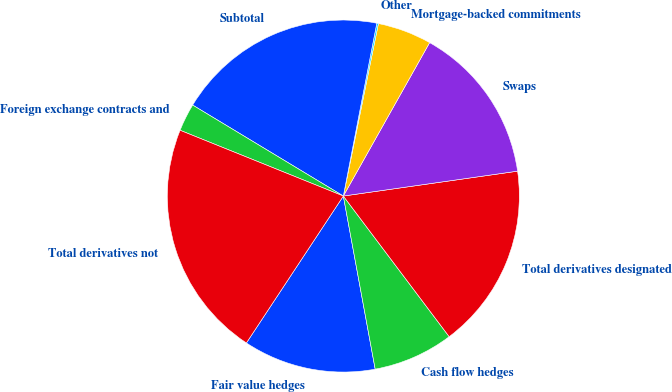Convert chart to OTSL. <chart><loc_0><loc_0><loc_500><loc_500><pie_chart><fcel>Fair value hedges<fcel>Cash flow hedges<fcel>Total derivatives designated<fcel>Swaps<fcel>Mortgage-backed commitments<fcel>Other<fcel>Subtotal<fcel>Foreign exchange contracts and<fcel>Total derivatives not<nl><fcel>12.18%<fcel>7.37%<fcel>16.99%<fcel>14.59%<fcel>4.96%<fcel>0.15%<fcel>19.4%<fcel>2.55%<fcel>21.81%<nl></chart> 